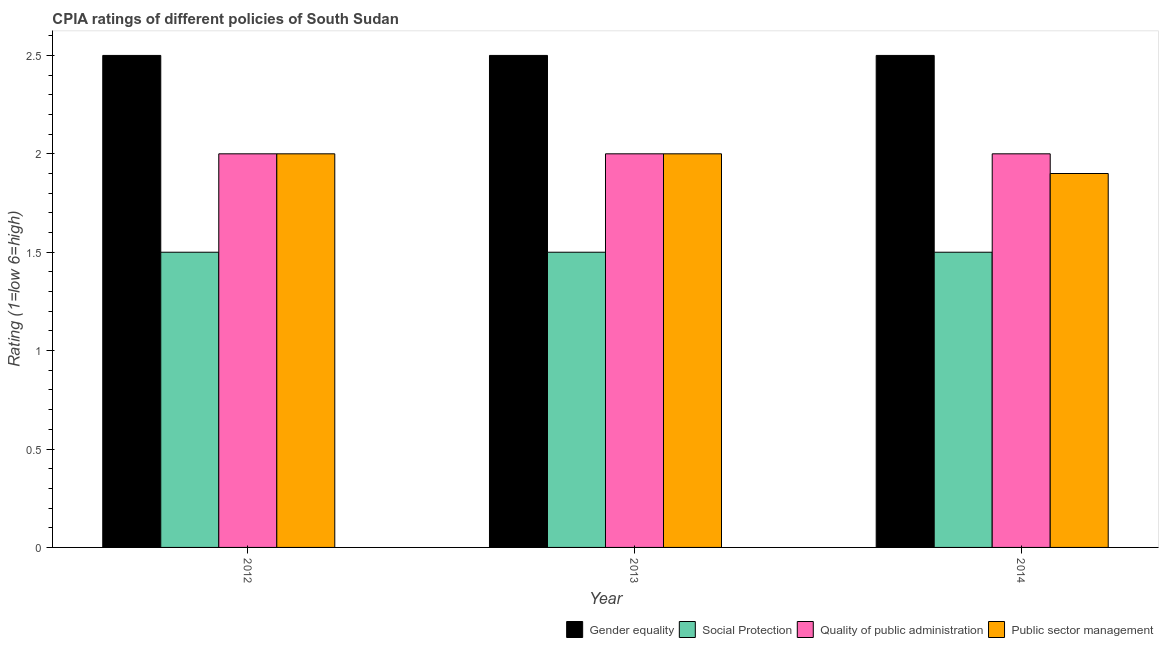What is the label of the 1st group of bars from the left?
Provide a succinct answer. 2012. What is the cpia rating of public sector management in 2013?
Give a very brief answer. 2. Across all years, what is the maximum cpia rating of social protection?
Keep it short and to the point. 1.5. What is the difference between the cpia rating of public sector management in 2012 and that in 2014?
Your answer should be very brief. 0.1. What is the average cpia rating of quality of public administration per year?
Offer a very short reply. 2. What is the ratio of the cpia rating of social protection in 2012 to that in 2014?
Your response must be concise. 1. Is the cpia rating of quality of public administration in 2013 less than that in 2014?
Make the answer very short. No. Is the difference between the cpia rating of gender equality in 2013 and 2014 greater than the difference between the cpia rating of quality of public administration in 2013 and 2014?
Your answer should be compact. No. What is the difference between the highest and the lowest cpia rating of social protection?
Provide a succinct answer. 0. Is the sum of the cpia rating of social protection in 2012 and 2014 greater than the maximum cpia rating of gender equality across all years?
Your answer should be very brief. Yes. What does the 3rd bar from the left in 2014 represents?
Make the answer very short. Quality of public administration. What does the 2nd bar from the right in 2012 represents?
Give a very brief answer. Quality of public administration. What is the difference between two consecutive major ticks on the Y-axis?
Offer a very short reply. 0.5. Does the graph contain any zero values?
Make the answer very short. No. Where does the legend appear in the graph?
Give a very brief answer. Bottom right. How many legend labels are there?
Your response must be concise. 4. What is the title of the graph?
Give a very brief answer. CPIA ratings of different policies of South Sudan. What is the label or title of the X-axis?
Make the answer very short. Year. What is the Rating (1=low 6=high) of Social Protection in 2012?
Give a very brief answer. 1.5. What is the Rating (1=low 6=high) in Public sector management in 2012?
Offer a very short reply. 2. What is the Rating (1=low 6=high) in Gender equality in 2013?
Provide a short and direct response. 2.5. What is the Rating (1=low 6=high) in Quality of public administration in 2013?
Make the answer very short. 2. Across all years, what is the maximum Rating (1=low 6=high) in Social Protection?
Provide a short and direct response. 1.5. Across all years, what is the maximum Rating (1=low 6=high) in Quality of public administration?
Give a very brief answer. 2. Across all years, what is the minimum Rating (1=low 6=high) in Social Protection?
Give a very brief answer. 1.5. What is the total Rating (1=low 6=high) in Gender equality in the graph?
Offer a terse response. 7.5. What is the total Rating (1=low 6=high) in Social Protection in the graph?
Keep it short and to the point. 4.5. What is the total Rating (1=low 6=high) of Quality of public administration in the graph?
Keep it short and to the point. 6. What is the total Rating (1=low 6=high) of Public sector management in the graph?
Ensure brevity in your answer.  5.9. What is the difference between the Rating (1=low 6=high) in Public sector management in 2012 and that in 2013?
Your answer should be very brief. 0. What is the difference between the Rating (1=low 6=high) in Gender equality in 2012 and that in 2014?
Give a very brief answer. 0. What is the difference between the Rating (1=low 6=high) in Social Protection in 2012 and that in 2014?
Offer a very short reply. 0. What is the difference between the Rating (1=low 6=high) in Quality of public administration in 2012 and that in 2014?
Make the answer very short. 0. What is the difference between the Rating (1=low 6=high) of Public sector management in 2012 and that in 2014?
Make the answer very short. 0.1. What is the difference between the Rating (1=low 6=high) in Gender equality in 2012 and the Rating (1=low 6=high) in Social Protection in 2013?
Provide a succinct answer. 1. What is the difference between the Rating (1=low 6=high) in Gender equality in 2012 and the Rating (1=low 6=high) in Quality of public administration in 2013?
Your response must be concise. 0.5. What is the difference between the Rating (1=low 6=high) of Social Protection in 2012 and the Rating (1=low 6=high) of Quality of public administration in 2013?
Offer a terse response. -0.5. What is the difference between the Rating (1=low 6=high) of Social Protection in 2012 and the Rating (1=low 6=high) of Public sector management in 2013?
Offer a terse response. -0.5. What is the difference between the Rating (1=low 6=high) in Gender equality in 2012 and the Rating (1=low 6=high) in Social Protection in 2014?
Your response must be concise. 1. What is the difference between the Rating (1=low 6=high) of Gender equality in 2012 and the Rating (1=low 6=high) of Quality of public administration in 2014?
Keep it short and to the point. 0.5. What is the difference between the Rating (1=low 6=high) in Social Protection in 2012 and the Rating (1=low 6=high) in Public sector management in 2014?
Provide a short and direct response. -0.4. What is the difference between the Rating (1=low 6=high) of Quality of public administration in 2012 and the Rating (1=low 6=high) of Public sector management in 2014?
Provide a short and direct response. 0.1. What is the difference between the Rating (1=low 6=high) of Gender equality in 2013 and the Rating (1=low 6=high) of Social Protection in 2014?
Give a very brief answer. 1. What is the difference between the Rating (1=low 6=high) of Gender equality in 2013 and the Rating (1=low 6=high) of Quality of public administration in 2014?
Offer a very short reply. 0.5. What is the difference between the Rating (1=low 6=high) in Gender equality in 2013 and the Rating (1=low 6=high) in Public sector management in 2014?
Keep it short and to the point. 0.6. What is the difference between the Rating (1=low 6=high) in Social Protection in 2013 and the Rating (1=low 6=high) in Public sector management in 2014?
Provide a short and direct response. -0.4. What is the average Rating (1=low 6=high) of Social Protection per year?
Provide a short and direct response. 1.5. What is the average Rating (1=low 6=high) of Quality of public administration per year?
Offer a terse response. 2. What is the average Rating (1=low 6=high) in Public sector management per year?
Give a very brief answer. 1.97. In the year 2012, what is the difference between the Rating (1=low 6=high) in Gender equality and Rating (1=low 6=high) in Quality of public administration?
Provide a short and direct response. 0.5. In the year 2012, what is the difference between the Rating (1=low 6=high) in Gender equality and Rating (1=low 6=high) in Public sector management?
Your answer should be compact. 0.5. In the year 2013, what is the difference between the Rating (1=low 6=high) in Gender equality and Rating (1=low 6=high) in Quality of public administration?
Offer a terse response. 0.5. In the year 2013, what is the difference between the Rating (1=low 6=high) in Gender equality and Rating (1=low 6=high) in Public sector management?
Your answer should be very brief. 0.5. In the year 2013, what is the difference between the Rating (1=low 6=high) in Social Protection and Rating (1=low 6=high) in Quality of public administration?
Your response must be concise. -0.5. In the year 2013, what is the difference between the Rating (1=low 6=high) in Quality of public administration and Rating (1=low 6=high) in Public sector management?
Your answer should be very brief. 0. In the year 2014, what is the difference between the Rating (1=low 6=high) of Gender equality and Rating (1=low 6=high) of Social Protection?
Offer a terse response. 1. In the year 2014, what is the difference between the Rating (1=low 6=high) of Gender equality and Rating (1=low 6=high) of Public sector management?
Ensure brevity in your answer.  0.6. In the year 2014, what is the difference between the Rating (1=low 6=high) in Social Protection and Rating (1=low 6=high) in Quality of public administration?
Provide a short and direct response. -0.5. What is the ratio of the Rating (1=low 6=high) of Quality of public administration in 2012 to that in 2013?
Provide a short and direct response. 1. What is the ratio of the Rating (1=low 6=high) of Gender equality in 2012 to that in 2014?
Give a very brief answer. 1. What is the ratio of the Rating (1=low 6=high) of Quality of public administration in 2012 to that in 2014?
Provide a succinct answer. 1. What is the ratio of the Rating (1=low 6=high) in Public sector management in 2012 to that in 2014?
Your response must be concise. 1.05. What is the ratio of the Rating (1=low 6=high) in Public sector management in 2013 to that in 2014?
Your answer should be compact. 1.05. What is the difference between the highest and the second highest Rating (1=low 6=high) of Gender equality?
Provide a short and direct response. 0. What is the difference between the highest and the second highest Rating (1=low 6=high) of Social Protection?
Your response must be concise. 0. What is the difference between the highest and the lowest Rating (1=low 6=high) of Gender equality?
Keep it short and to the point. 0. What is the difference between the highest and the lowest Rating (1=low 6=high) of Social Protection?
Offer a very short reply. 0. What is the difference between the highest and the lowest Rating (1=low 6=high) of Quality of public administration?
Your answer should be very brief. 0. What is the difference between the highest and the lowest Rating (1=low 6=high) of Public sector management?
Provide a succinct answer. 0.1. 